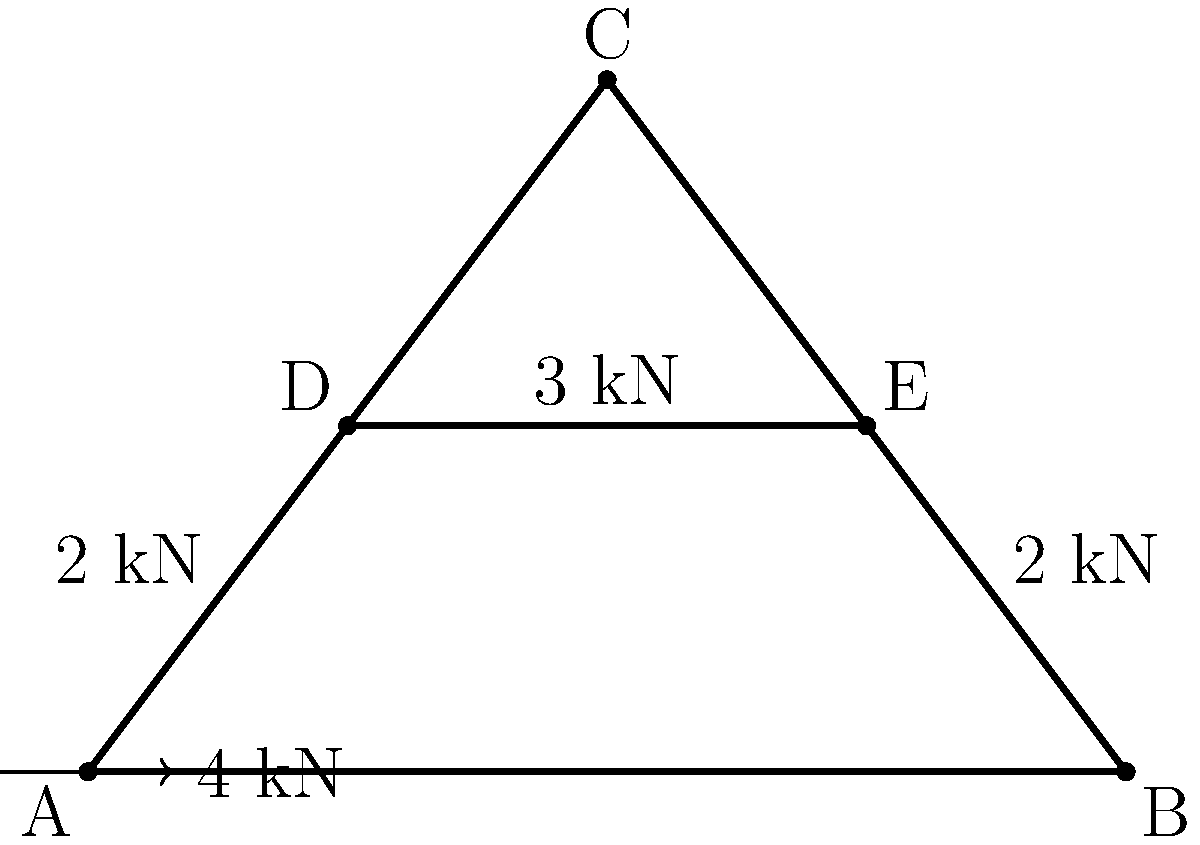Consider the truss structure shown in the figure. Using the method of joints, determine the force in member DE. Assume all joints are pin connections and the structure is in equilibrium. Express your answer in kN, using the appropriate sign convention (positive for tension, negative for compression). To solve this problem using the method of joints, we'll follow these steps:

1) First, we need to calculate the reaction forces at supports A and B.

2) For vertical equilibrium:
   $$\sum F_y = 0: R_{Ay} + R_{By} - 2 - 2 - 3 = 0$$
   $$R_{Ay} + R_{By} = 7 \text{ kN}$$

3) For moment equilibrium about A:
   $$\sum M_A = 0: 6R_{By} - 2(6) - 3(3) - 2(1.5) = 0$$
   $$6R_{By} = 12 + 9 + 3 = 24$$
   $$R_{By} = 4 \text{ kN}$$

4) Therefore, $R_{Ay} = 7 - 4 = 3 \text{ kN}$

5) For horizontal equilibrium:
   $$\sum F_x = 0: R_{Ax} - 4 = 0$$
   $$R_{Ax} = 4 \text{ kN}$$

6) Now, let's analyze joint D:
   
   For vertical equilibrium:
   $$\sum F_y = 0: F_{DC} \sin 60° - 2 = 0$$
   $$F_{DC} = \frac{2}{\sin 60°} = 2.31 \text{ kN}$$ (tension)

   For horizontal equilibrium:
   $$\sum F_x = 0: F_{DE} + F_{DC} \cos 60° - 2 = 0$$
   $$F_{DE} = 2 - F_{DC} \cos 60° = 2 - 2.31 \cos 60° = 0.845 \text{ kN}$$

7) Therefore, the force in member DE is 0.845 kN (tension).
Answer: 0.845 kN 